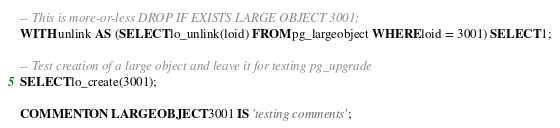<code> <loc_0><loc_0><loc_500><loc_500><_SQL_>
-- This is more-or-less DROP IF EXISTS LARGE OBJECT 3001;
WITH unlink AS (SELECT lo_unlink(loid) FROM pg_largeobject WHERE loid = 3001) SELECT 1;

-- Test creation of a large object and leave it for testing pg_upgrade
SELECT lo_create(3001);

COMMENT ON LARGE OBJECT 3001 IS 'testing comments';
</code> 